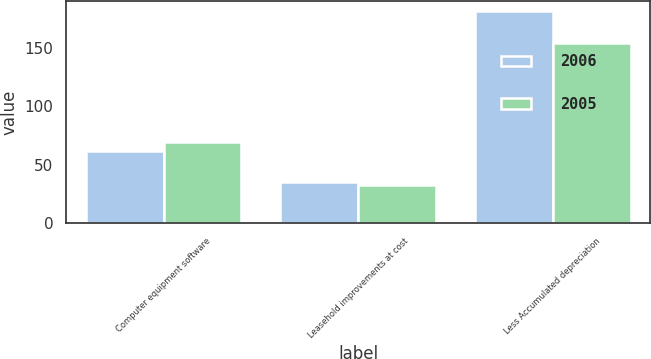Convert chart. <chart><loc_0><loc_0><loc_500><loc_500><stacked_bar_chart><ecel><fcel>Computer equipment software<fcel>Leasehold improvements at cost<fcel>Less Accumulated depreciation<nl><fcel>2006<fcel>61.4<fcel>35<fcel>181.6<nl><fcel>2005<fcel>69.6<fcel>32.6<fcel>154.7<nl></chart> 